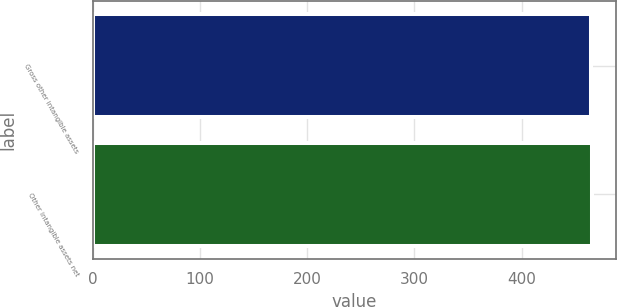Convert chart. <chart><loc_0><loc_0><loc_500><loc_500><bar_chart><fcel>Gross other intangible assets<fcel>Other intangible assets net<nl><fcel>465<fcel>465.1<nl></chart> 